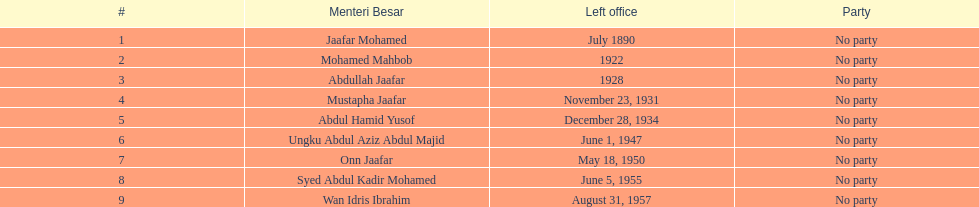Help me parse the entirety of this table. {'header': ['#', 'Menteri Besar', 'Left office', 'Party'], 'rows': [['1', 'Jaafar Mohamed', 'July 1890', 'No party'], ['2', 'Mohamed Mahbob', '1922', 'No party'], ['3', 'Abdullah Jaafar', '1928', 'No party'], ['4', 'Mustapha Jaafar', 'November 23, 1931', 'No party'], ['5', 'Abdul Hamid Yusof', 'December 28, 1934', 'No party'], ['6', 'Ungku Abdul Aziz Abdul Majid', 'June 1, 1947', 'No party'], ['7', 'Onn Jaafar', 'May 18, 1950', 'No party'], ['8', 'Syed Abdul Kadir Mohamed', 'June 5, 1955', 'No party'], ['9', 'Wan Idris Ibrahim', 'August 31, 1957', 'No party']]} How long did ungku abdul aziz abdul majid serve? 12 years. 